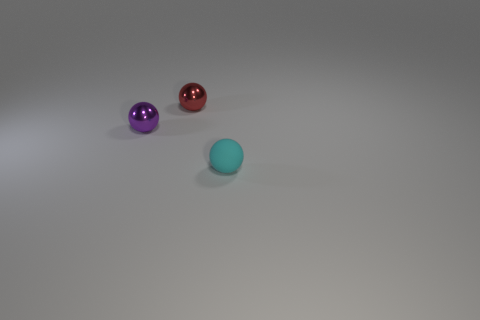There is a ball in front of the small metallic thing that is in front of the red metallic thing; what size is it?
Your answer should be compact. Small. Is the shape of the small matte object that is right of the red thing the same as  the tiny red object?
Provide a short and direct response. Yes. There is a tiny cyan object that is the same shape as the small purple shiny object; what is it made of?
Make the answer very short. Rubber. How many objects are things that are on the left side of the small cyan matte object or objects in front of the purple sphere?
Offer a very short reply. 3. Does the rubber ball have the same color as the metal ball behind the purple ball?
Keep it short and to the point. No. The red object that is the same material as the tiny purple thing is what shape?
Ensure brevity in your answer.  Sphere. What number of big purple matte cylinders are there?
Give a very brief answer. 0. What number of objects are either small objects that are behind the rubber object or small objects?
Give a very brief answer. 3. There is a small metallic object that is behind the purple metal thing; is its color the same as the rubber ball?
Keep it short and to the point. No. How many other things are the same color as the small rubber sphere?
Provide a succinct answer. 0. 